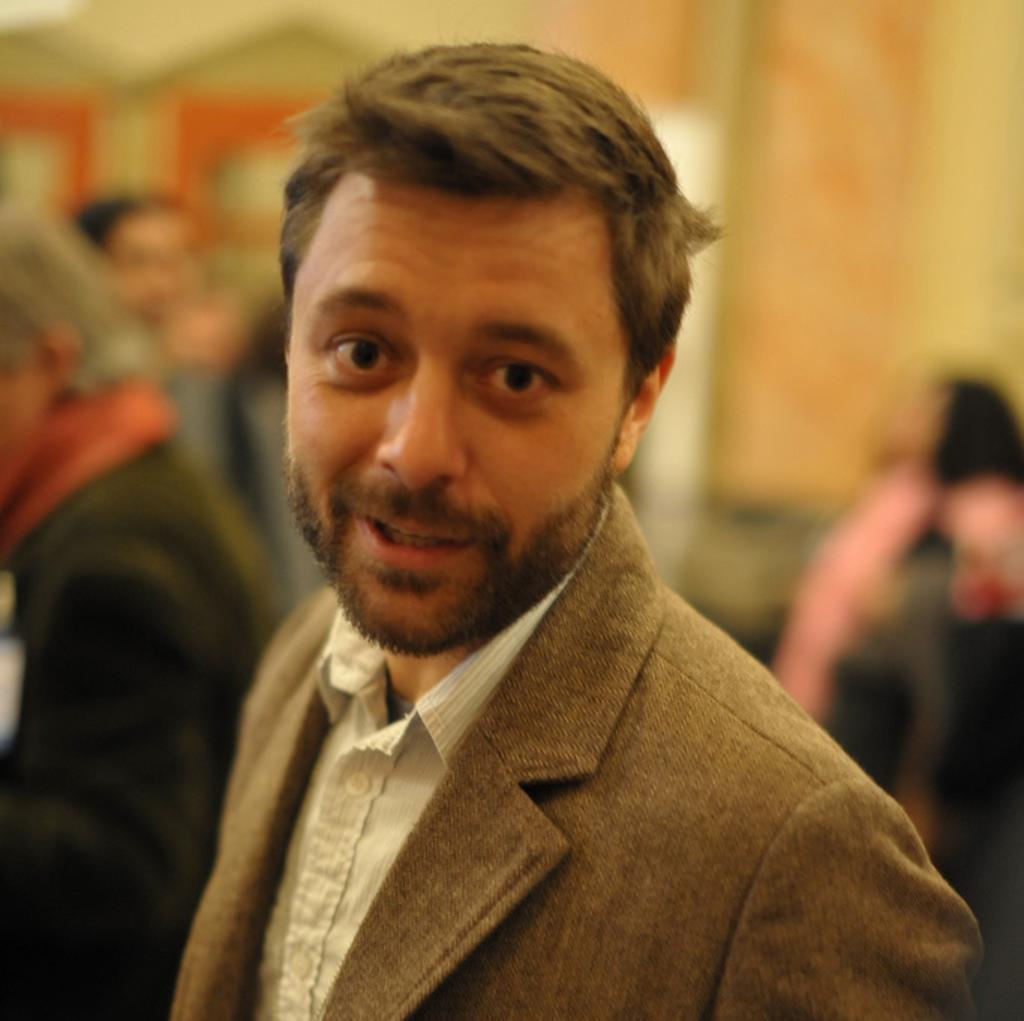Can you describe this image briefly? In this image in the center there is a man standing and smiling and the background is blurry. 